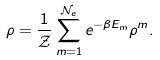<formula> <loc_0><loc_0><loc_500><loc_500>\rho = \frac { 1 } { \mathcal { Z } } \sum _ { m = 1 } ^ { \mathcal { N } _ { e } } e ^ { - \beta E _ { m } } \rho ^ { m } .</formula> 